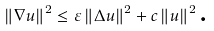Convert formula to latex. <formula><loc_0><loc_0><loc_500><loc_500>\left \| \nabla u \right \| ^ { 2 } \leq \varepsilon \left \| \Delta u \right \| ^ { 2 } + c \left \| u \right \| ^ { 2 } \text {.}</formula> 